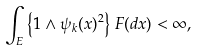<formula> <loc_0><loc_0><loc_500><loc_500>\int _ { E } \left \{ 1 \wedge \psi _ { k } ( x ) ^ { 2 } \right \} \, F ( d x ) < \infty ,</formula> 